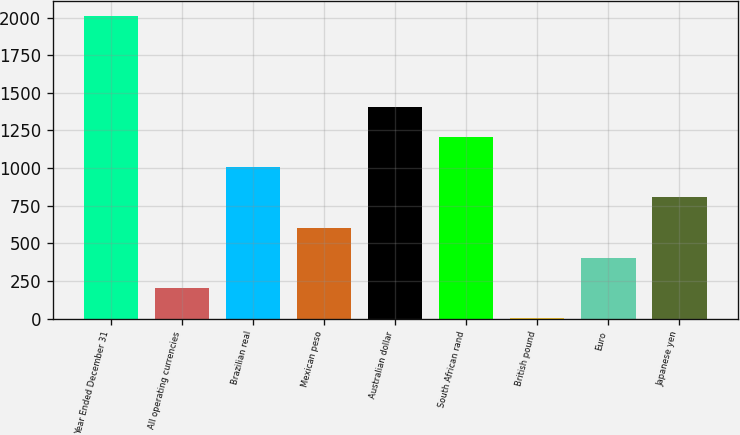Convert chart to OTSL. <chart><loc_0><loc_0><loc_500><loc_500><bar_chart><fcel>Year Ended December 31<fcel>All operating currencies<fcel>Brazilian real<fcel>Mexican peso<fcel>Australian dollar<fcel>South African rand<fcel>British pound<fcel>Euro<fcel>Japanese yen<nl><fcel>2010<fcel>202.8<fcel>1006<fcel>604.4<fcel>1407.6<fcel>1206.8<fcel>2<fcel>403.6<fcel>805.2<nl></chart> 